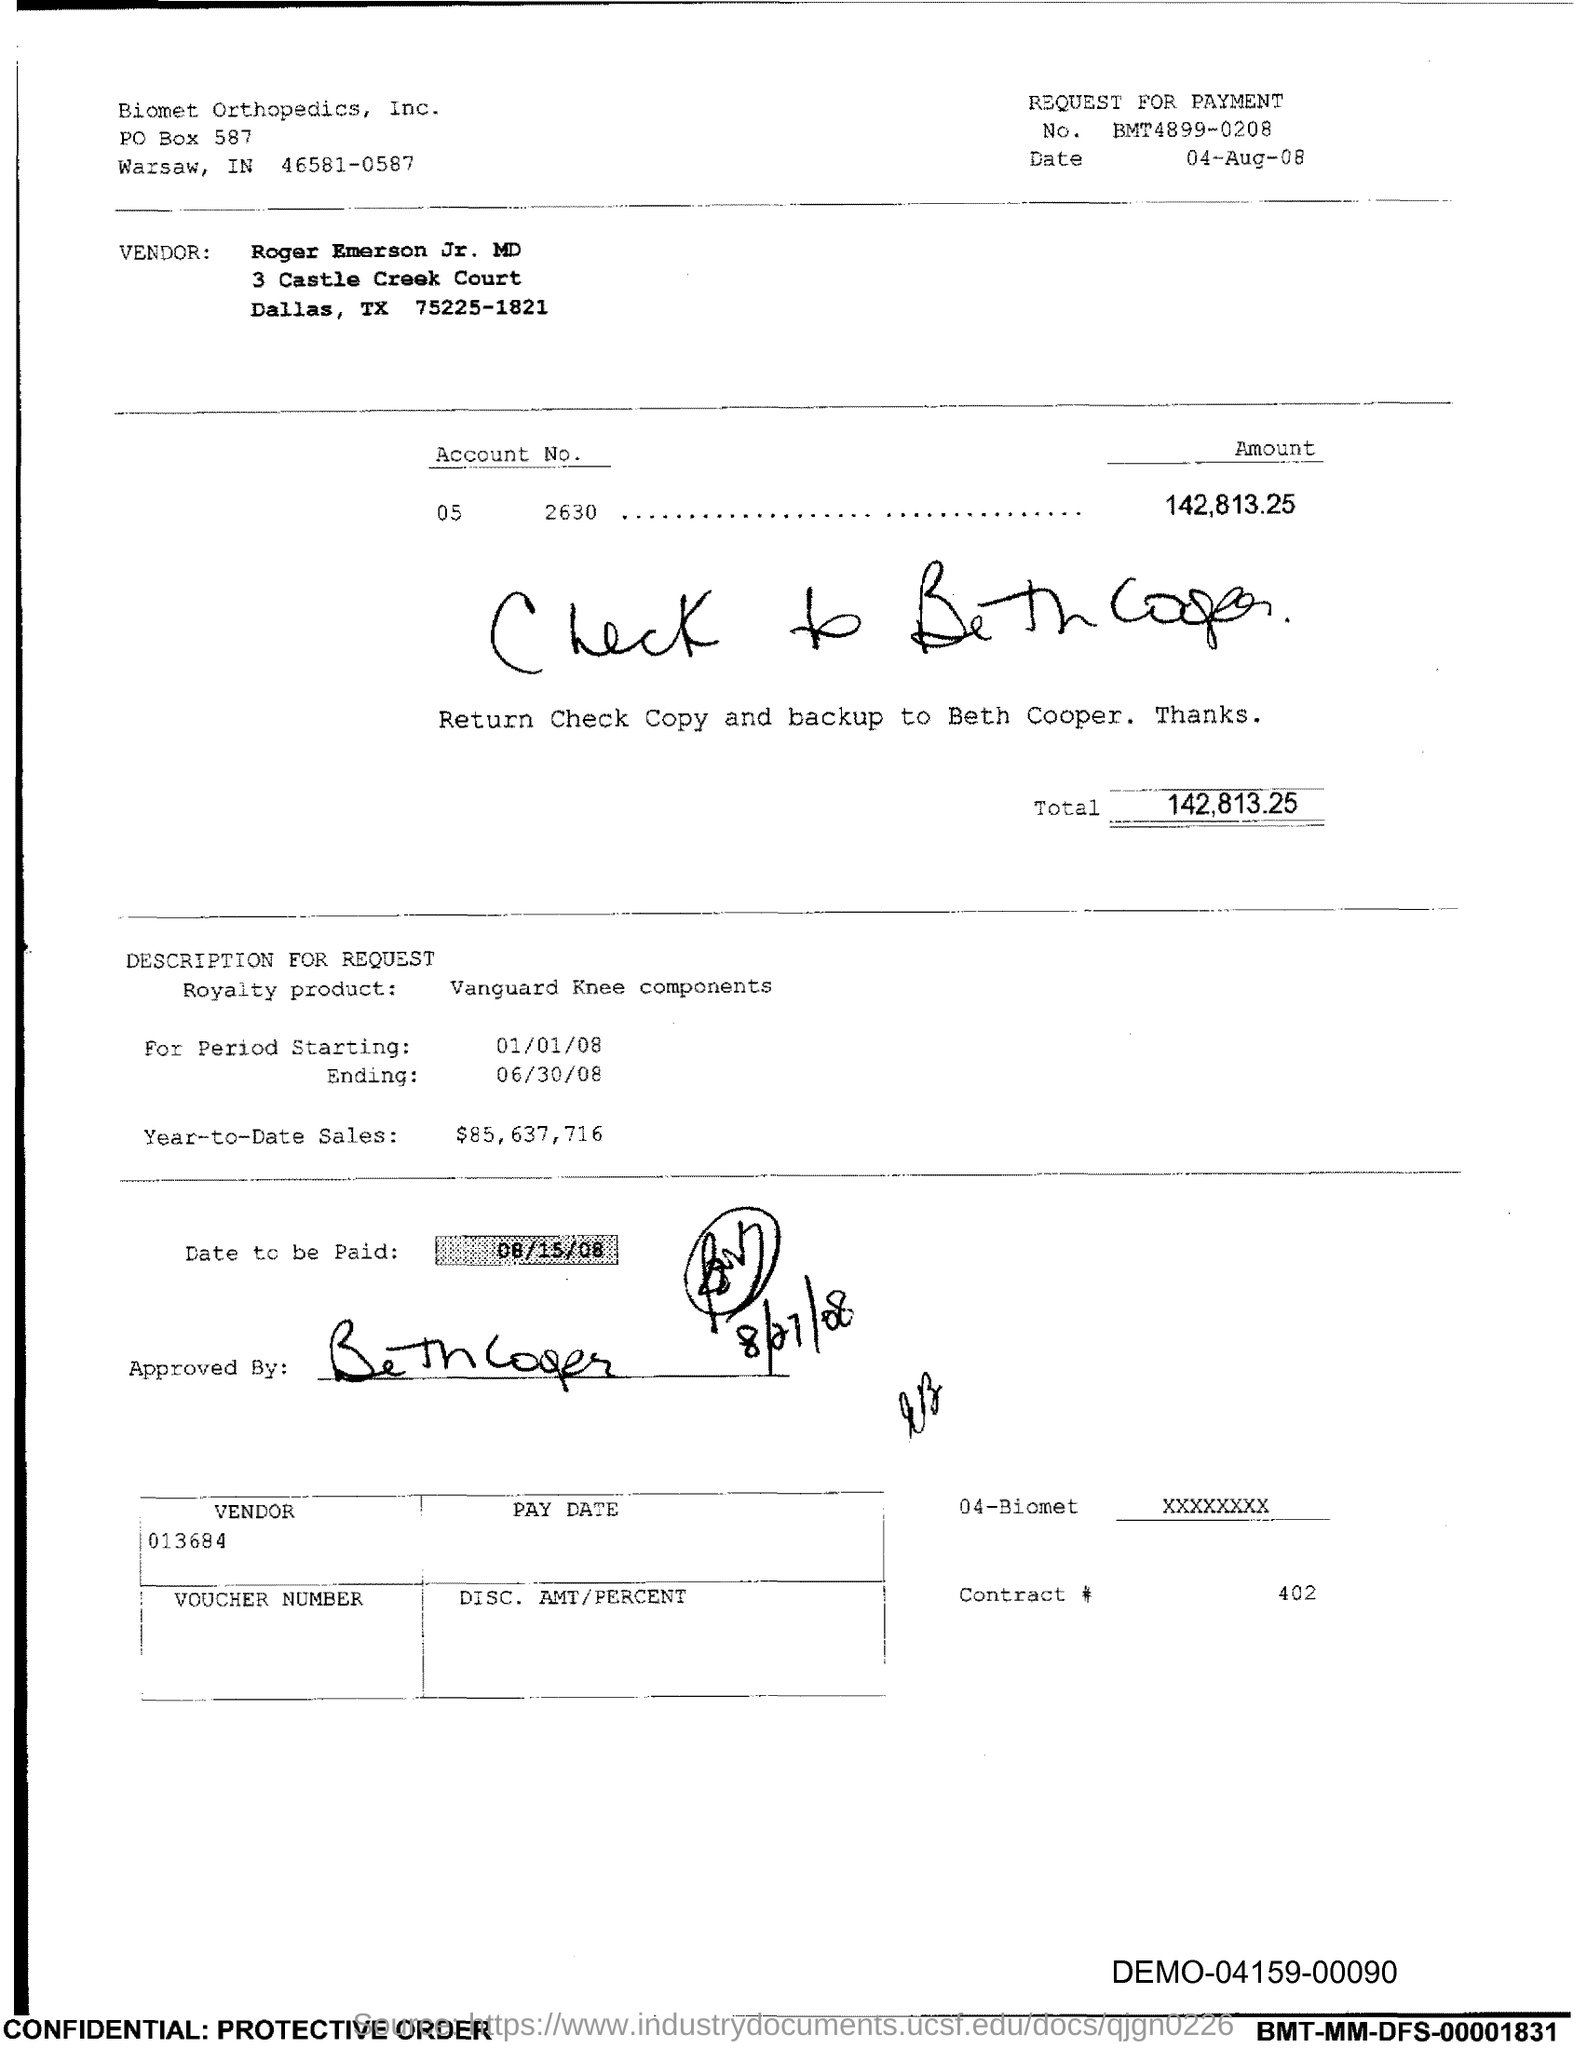What is the date mentioned on the top right corner?
Your answer should be very brief. 04-aug-08. How much is the total amount?
Provide a succinct answer. 142,813.25. What is the royalty product?
Provide a short and direct response. VANGUARD KNEE COMPONENTS. To whom should the check copy and backup returned to?
Ensure brevity in your answer.  Beth cooper. What is the date to be paid?
Ensure brevity in your answer.  08/15/08. What is the vendor code?
Make the answer very short. 013684. What is the contract #?
Your answer should be compact. 402. How much is the year to date sales amount?
Ensure brevity in your answer.  $85,637,716. 